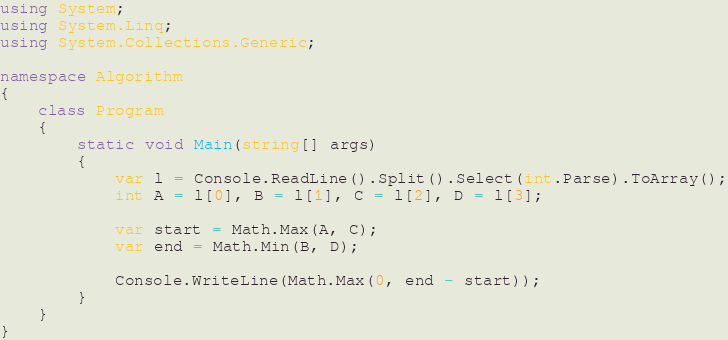<code> <loc_0><loc_0><loc_500><loc_500><_C#_>using System;
using System.Linq;
using System.Collections.Generic;

namespace Algorithm
{
    class Program
    {
        static void Main(string[] args)
        {
            var l = Console.ReadLine().Split().Select(int.Parse).ToArray();
            int A = l[0], B = l[1], C = l[2], D = l[3];

            var start = Math.Max(A, C);
            var end = Math.Min(B, D);

            Console.WriteLine(Math.Max(0, end - start));
        }
    }
}
</code> 